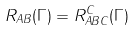Convert formula to latex. <formula><loc_0><loc_0><loc_500><loc_500>R _ { A B } ( \Gamma ) = R ^ { C } _ { A B C } ( \Gamma )</formula> 